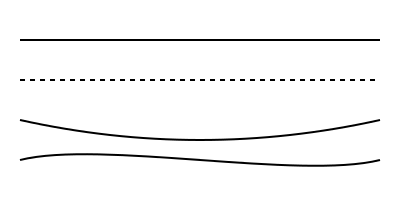Identify the brush stroke technique that best represents a critique of societal privilege while maintaining artistic integrity. Which of the illustrated stroke patterns would you choose to make a statement about the disparity between genuine artistic struggle and affected poverty? 1. Solid line: Represents a straightforward, traditional approach. While clear, it lacks the nuance needed to critique societal issues.

2. Dashed line: Symbolizes discontinuity and fragmentation. This could represent the broken narratives of those affected by privilege masquerading as poverty, but it may be too subtle.

3. Curved line (top): Shows a gentle, flowing movement. While aesthetically pleasing, it doesn't convey the tension inherent in the subject matter.

4. Curved line with varying pressure (bottom): This technique, known as "expressive line," demonstrates varying thickness and intensity. It best represents the complexity and emotional depth required to critique privilege masquerading as poverty.

The bottom curve, created with varying pressure, allows for the most expressive and nuanced representation. It can symbolize the ebb and flow of societal pressures, the weight of privilege, and the struggle of genuine artistic poverty. This technique enables the artist to convey emotion and critique through the intensity and character of the line itself, making it the most suitable choice for addressing complex social issues through art.
Answer: Expressive line (bottom curve) 